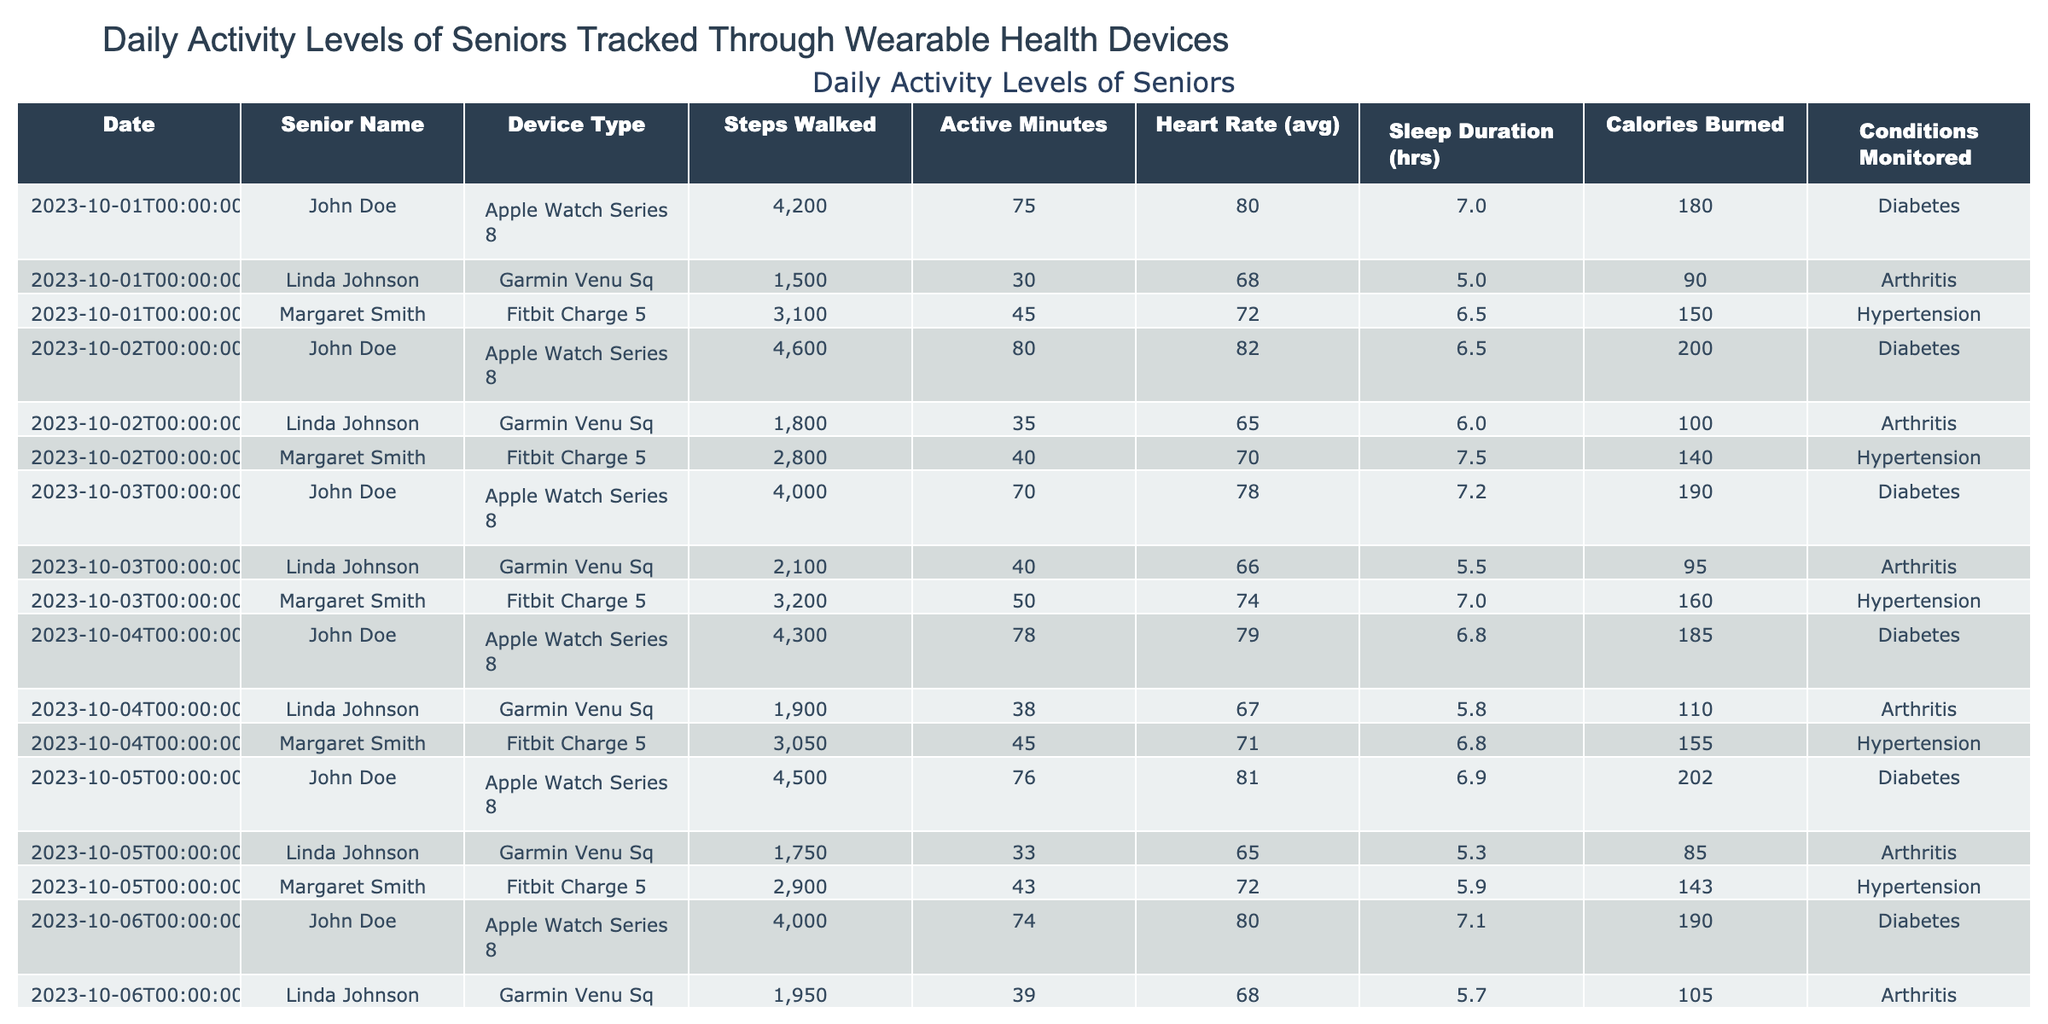What was the highest number of steps walked by any senior on October 1st? On October 1st, the data shows that John Doe walked 4200 steps, which is the highest among the recorded seniors on that day.
Answer: 4200 What is the average heart rate for Margaret Smith over the four days? To find the average heart rate for Margaret Smith, we add her heart rates for each day: 72 + 70 + 74 + 71 = 287. Then we divide by the number of days (4): 287 / 4 = 71.75.
Answer: 71.75 Did Linda Johnson sleep for more than six hours on each of the recorded days? Reviewing Linda Johnson's sleep duration, she slept for 5.0, 6.0, 5.5, 5.8, and 5.3 hours over the recorded days, which is less than six hours on all days.
Answer: No How many active minutes did John Doe accumulate over the five days? John Doe's active minutes were 75, 80, 70, 78, and 76 over the five days. Adding these gives: 75 + 80 + 70 + 78 + 76 = 379 active minutes.
Answer: 379 Which senior walked the least number of steps on October 3rd, and how many steps did they walk? On October 3rd, Margaret Smith walked 3200 steps, John Doe walked 4000 steps, and Linda Johnson walked 2100 steps. Linda Johnson had the least steps.
Answer: Linda Johnson, 2100 What is the total calories burned by Margaret Smith across all days? The calories burned by Margaret Smith are: 150, 140, 160, 155, and 143. Summing these gives: 150 + 140 + 160 + 155 + 143 = 748 calories burned in total.
Answer: 748 Which device had the lowest average steps taken by seniors over the five days? First, we calculate the average steps for each device. Fitbit Charge 5 (Margaret Smith): (3100 + 2800 + 3200 + 3050 + 2900) / 5 = 3010. Apple Watch Series 8 (John Doe): (4200 + 4600 + 4000 + 4300 + 4500) / 5 = 4310. Garmin Venu Sq (Linda Johnson): (1500 + 1800 + 2100 + 1900 + 1750) / 5 = 1810. The Garmin Venu Sq had the lowest average steps.
Answer: Garmin Venu Sq What percentage of days did John Doe have an active duration of over 75 minutes? John Doe had active durations of 75, 80, 70, 78, and 76 minutes. The active durations over 75 minutes are 75, 80, 78, and 76 (4 days). So, the calculation is (4 / 5) * 100 = 80%.
Answer: 80% Who had the highest average sleep duration? Calculate the average sleep duration for each senior: Margaret Smith (6.5 + 7.5 + 7 + 6.8 + 5.9) / 5 = 6.54, John Doe (7 + 6.5 + 7.2 + 6.8 + 6.9) / 5 = 6.84, Linda Johnson (5.0 + 6.0 + 5.5 + 5.8 + 5.3) / 5 = 5.52. John Doe had the highest average sleep duration.
Answer: John Doe Did any senior burn more than 200 calories on a single day? Checking the calories burned, John Doe burned 200 calories on October 2 and 202 calories on October 5, while others did not exceed 200. Thus, he burned more than 200 calories on a single day.
Answer: Yes 